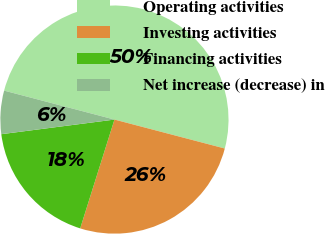<chart> <loc_0><loc_0><loc_500><loc_500><pie_chart><fcel>Operating activities<fcel>Investing activities<fcel>Financing activities<fcel>Net increase (decrease) in<nl><fcel>50.0%<fcel>25.77%<fcel>18.1%<fcel>6.13%<nl></chart> 